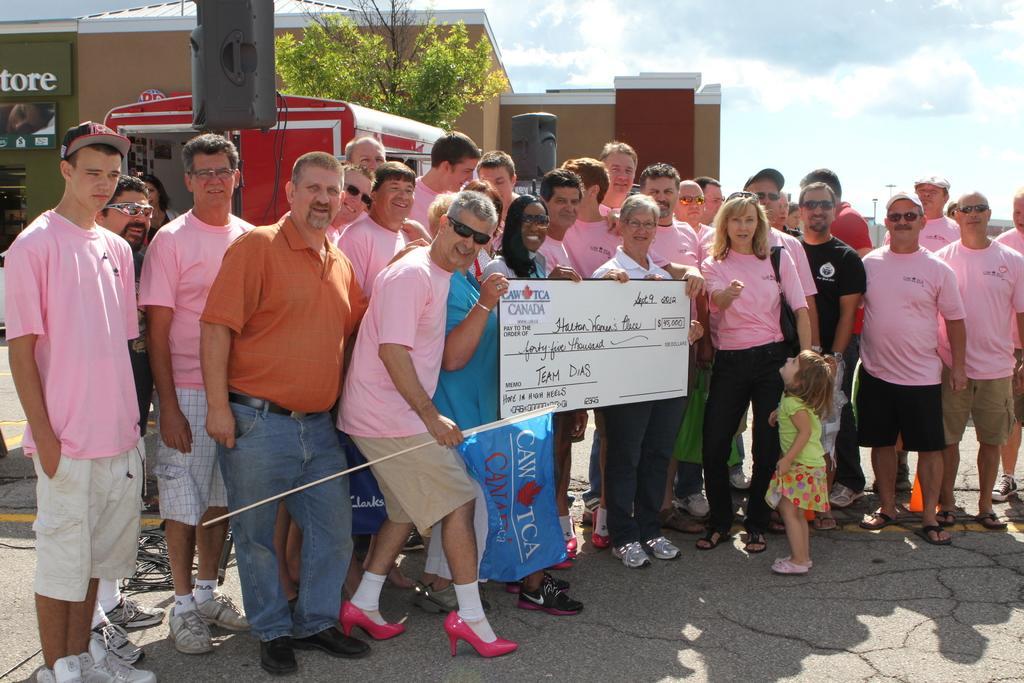How would you summarize this image in a sentence or two? In this image we can see there are people standing on the road and holding a flag and board. And at the back there is a building, tree, van, pole and the cloudy sky. 